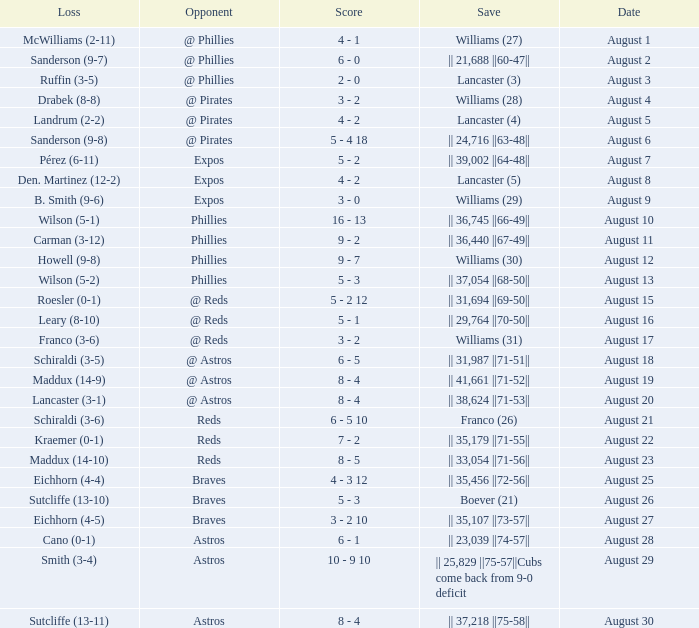Name the score for save of lancaster (3) 2 - 0. 